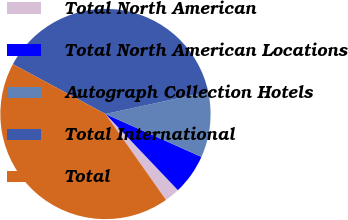<chart> <loc_0><loc_0><loc_500><loc_500><pie_chart><fcel>Total North American<fcel>Total North American Locations<fcel>Autograph Collection Hotels<fcel>Total International<fcel>Total<nl><fcel>2.33%<fcel>6.21%<fcel>10.08%<fcel>38.75%<fcel>42.62%<nl></chart> 